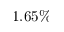Convert formula to latex. <formula><loc_0><loc_0><loc_500><loc_500>1 . 6 5 \%</formula> 